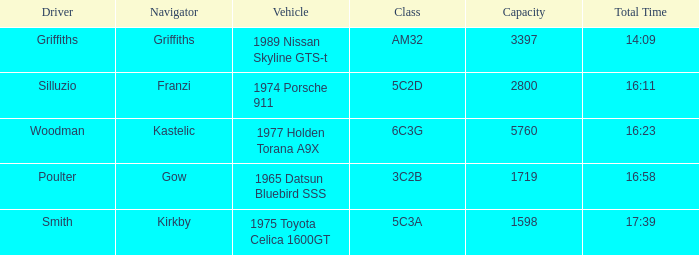What's the lowest capacity when the margin is 03:30? 1598.0. 